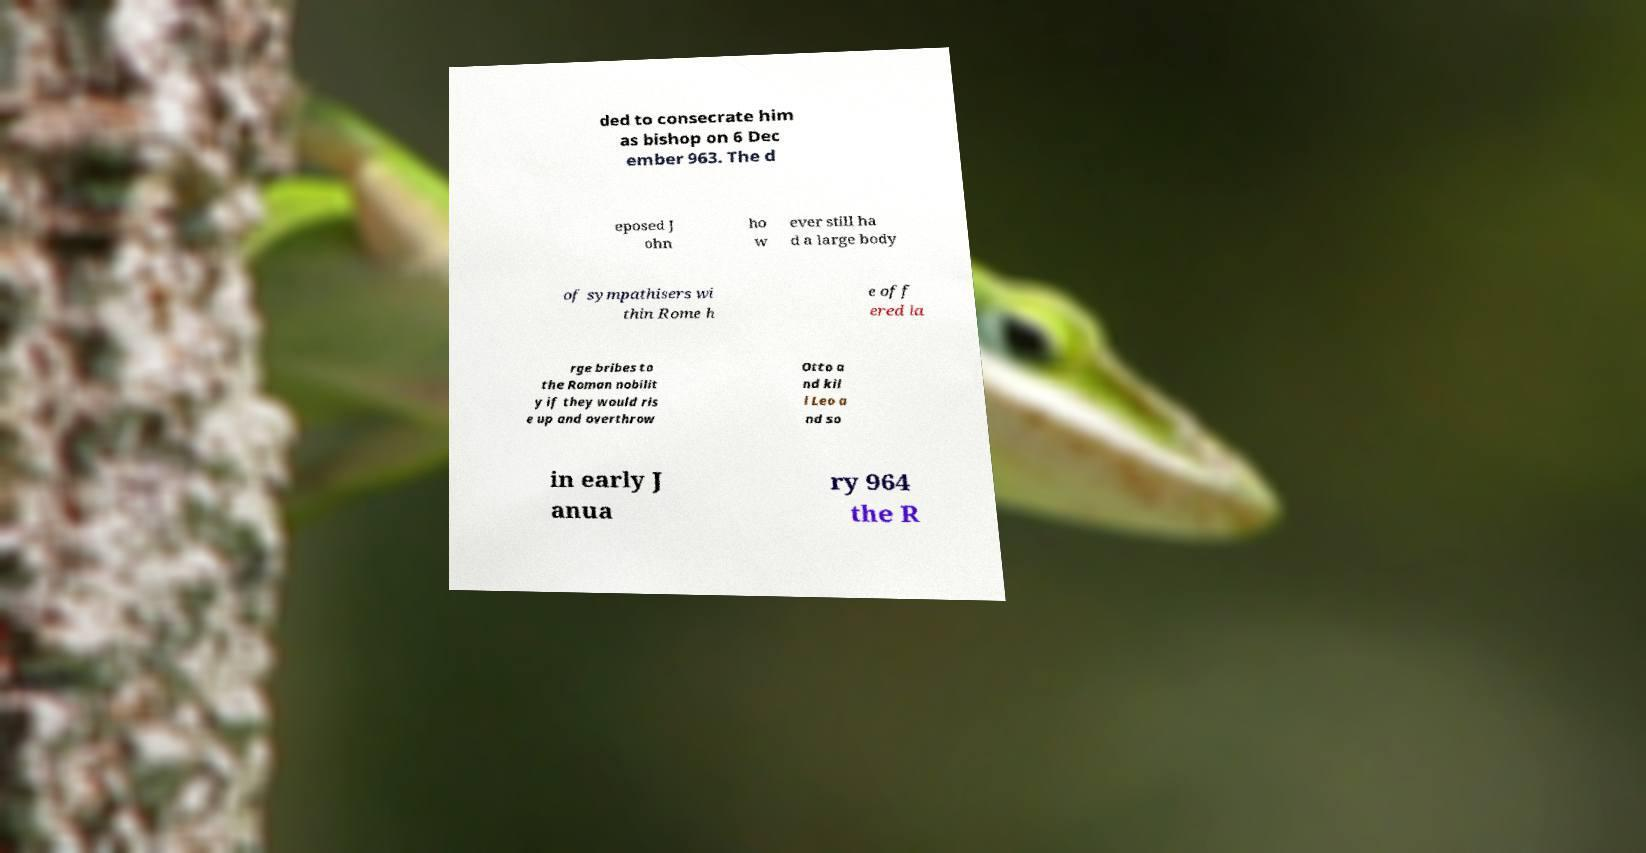Please identify and transcribe the text found in this image. ded to consecrate him as bishop on 6 Dec ember 963. The d eposed J ohn ho w ever still ha d a large body of sympathisers wi thin Rome h e off ered la rge bribes to the Roman nobilit y if they would ris e up and overthrow Otto a nd kil l Leo a nd so in early J anua ry 964 the R 